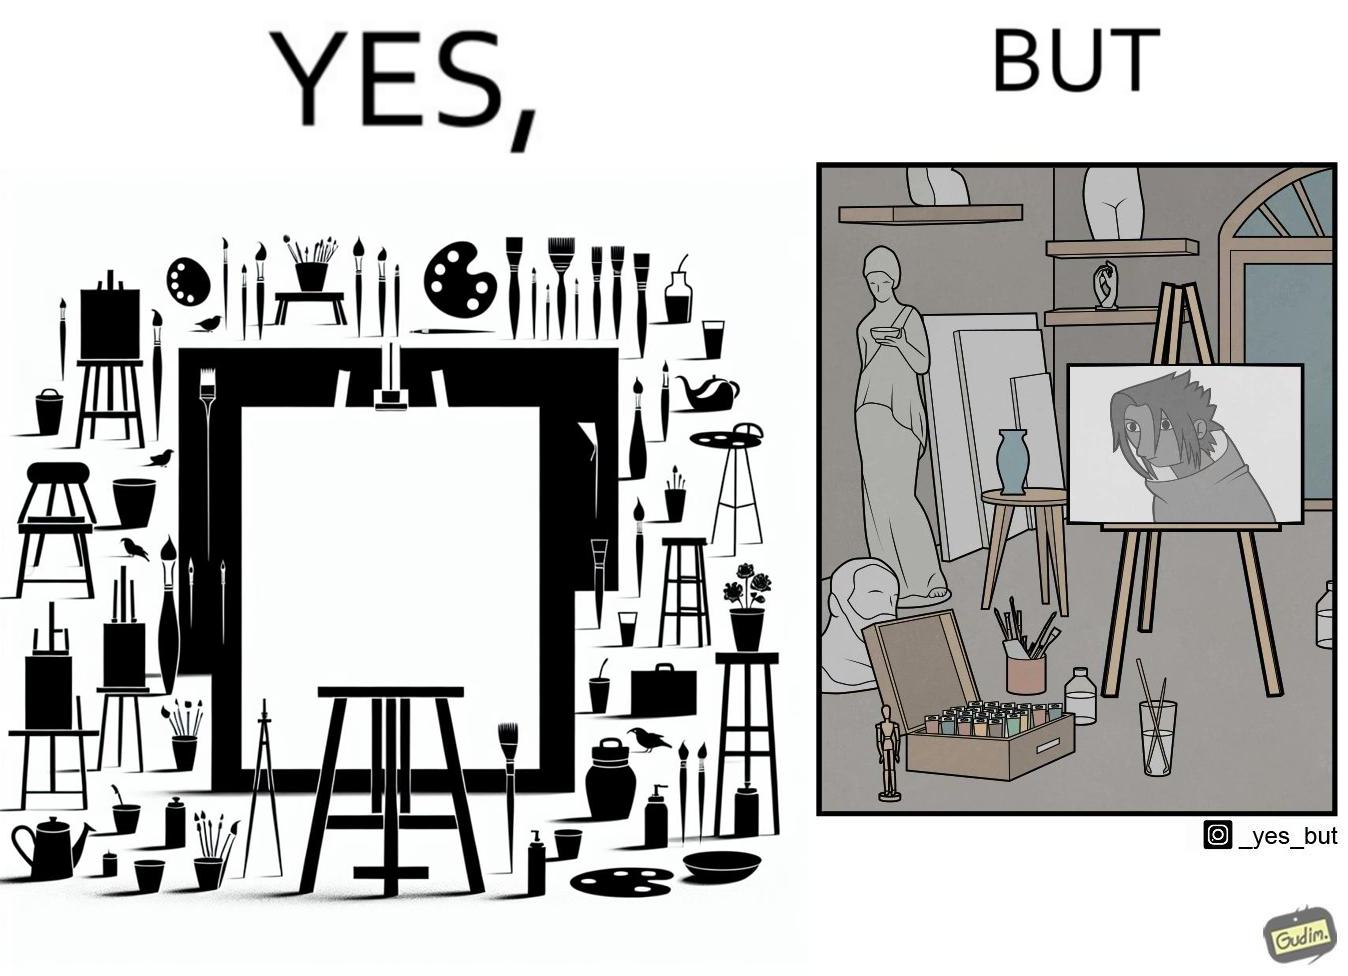What is the satirical meaning behind this image? The image is ironical, as even though the art studio contains a palette of a range of color paints, the painting on the canvas is black and white. 